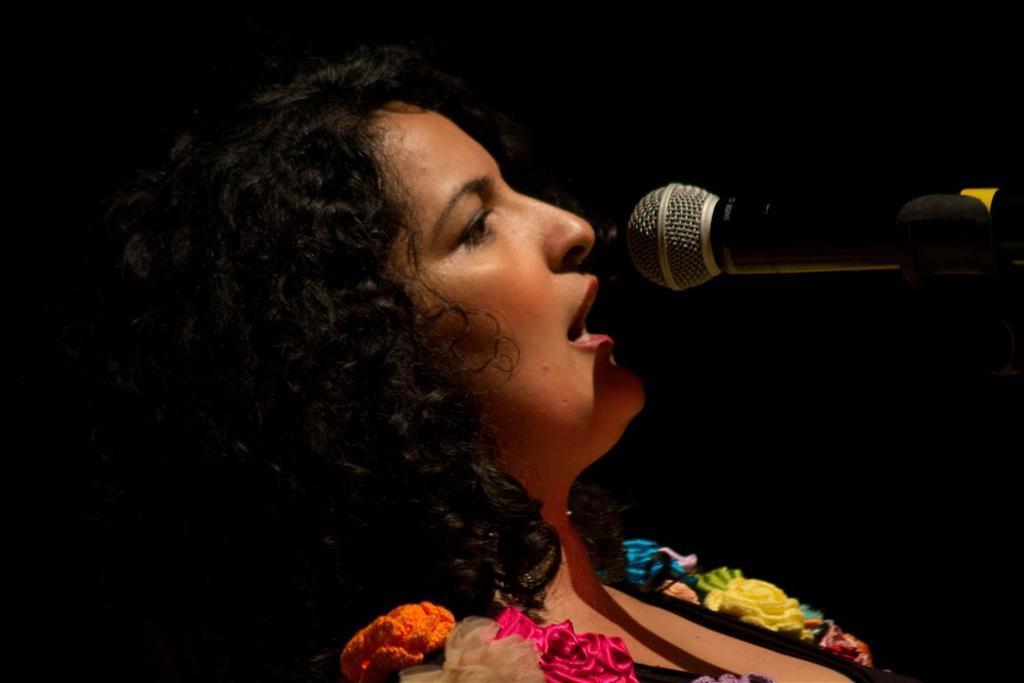Could you give a brief overview of what you see in this image? This is a zoomed in picture. In the center there is a person seems to be singing. On the right there is a microphone attached to the stand. The background of the image is very dark. 